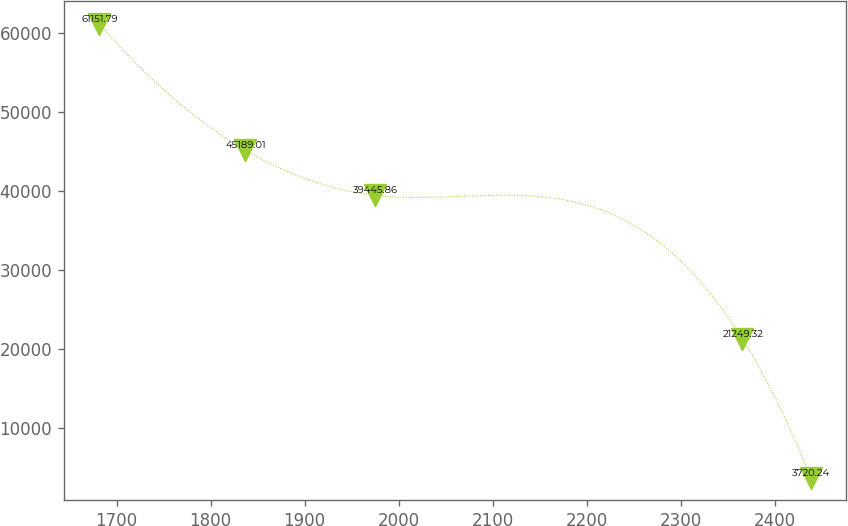Convert chart to OTSL. <chart><loc_0><loc_0><loc_500><loc_500><line_chart><ecel><fcel>Unnamed: 1<nl><fcel>1681.67<fcel>61151.8<nl><fcel>1836.54<fcel>45189<nl><fcel>1975.08<fcel>39445.9<nl><fcel>2365.85<fcel>21249.3<nl><fcel>2438.5<fcel>3720.24<nl></chart> 